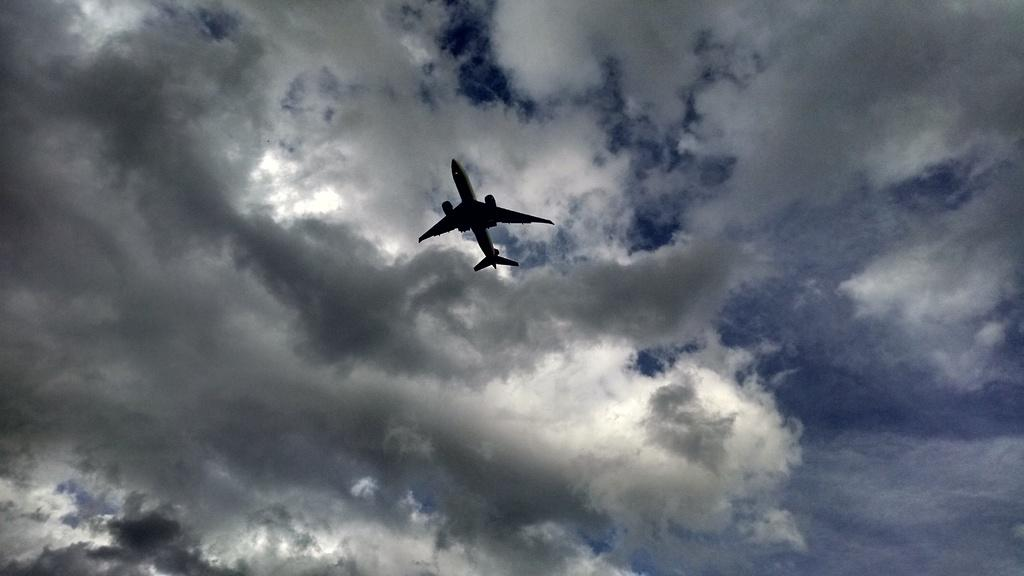What is the main subject of the image? The main subject of the image is an airplane. What is the airplane doing in the image? The airplane is flying in the air. What can be seen in the background of the image? There is sky visible in the background of the image. How would you describe the weather based on the sky in the image? The sky has heavy clouds, which might suggest overcast or stormy weather. What type of insect can be seen flying near the airplane in the image? There are no insects visible in the image; it only features an airplane flying in the sky. 